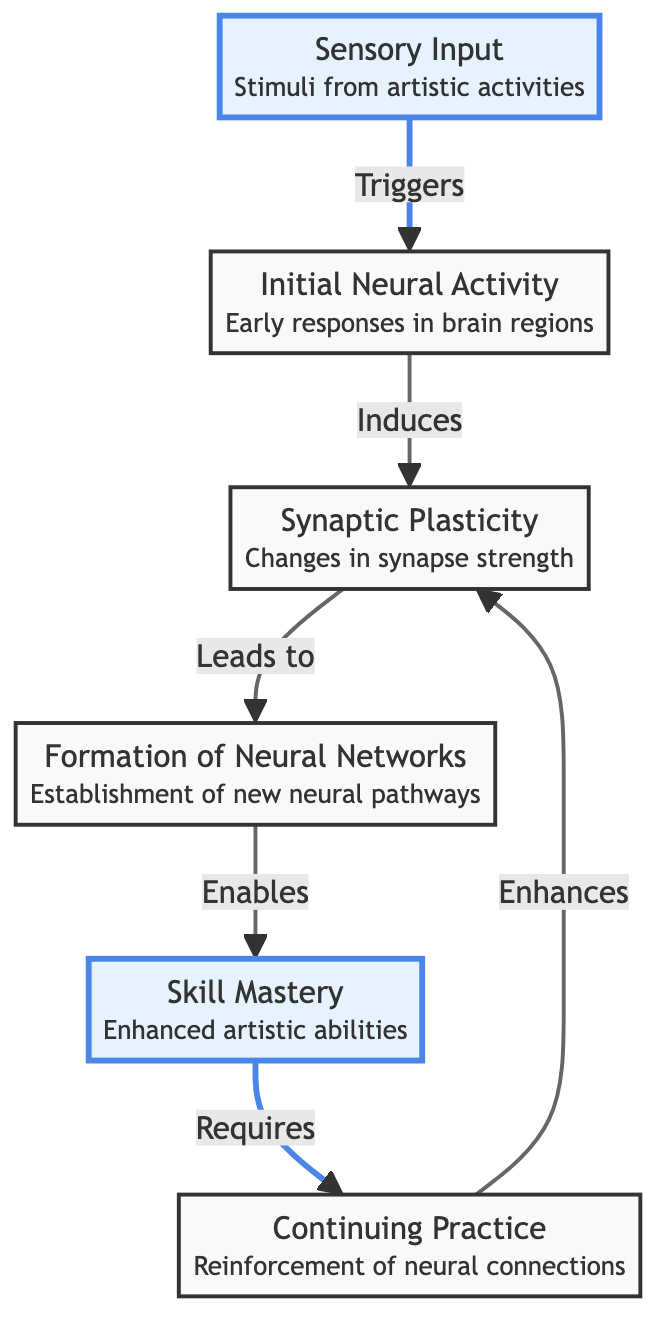What is the first node in the process of neuroplasticity? The first node in the diagram is labeled "Sensory Input," which indicates the entry point for stimuli from artistic activities.
Answer: Sensory Input How many nodes are present in the diagram? By counting the distinct elements in the diagram, we identify a total of six nodes: Sensory Input, Initial Neural Activity, Synaptic Plasticity, Neural Networks, Skill Mastery, and Continuing Practice.
Answer: 6 What does "Skill Mastery" lead to in the diagram? The diagram shows that "Skill Mastery" leads to "Continuing Practice," implying that achieving mastery in artistic skills requires ongoing practice.
Answer: Continuing Practice Which node highlights the concept of "Changes in synapse strength"? The node "Synaptic Plasticity" specifically emphasizes changes in the strength of synapses, which corresponds to neuroplastic changes during skill development.
Answer: Synaptic Plasticity What is the relationship between "Continuing Practice" and "Synaptic Plasticity"? The diagram illustrates that "Continuing Practice" enhances "Synaptic Plasticity," indicating that continued practice not only reinforces skills but also improves synaptic changes.
Answer: Enhances What is the final outcome of the neuroplasticity process depicted in the diagram? The final outcome depicted in the diagram is "Skill Mastery," highlighting the ultimate achievement of enhanced artistic abilities through the neuroplasticity process.
Answer: Skill Mastery What role does "Initial Neural Activity" play in the flow of neuroplasticity? "Initial Neural Activity" induces "Synaptic Plasticity," suggesting that early brain responses are crucial for initiating synaptic changes necessary for skill development.
Answer: Induces How does "Sensory Input" influence the neuroplasticity process? "Sensory Input" triggers "Initial Neural Activity," serving as the catalyst that starts the sequence leading to synaptic changes and skill development.
Answer: Triggers Which node is placed strategically between "Skill Mastery" and "Synaptic Plasticity" in the diagram? The node "Continuing Practice" is strategically placed between "Skill Mastery" and "Synaptic Plasticity," indicating its significance in the ongoing cycle of skill improvement.
Answer: Continuing Practice 